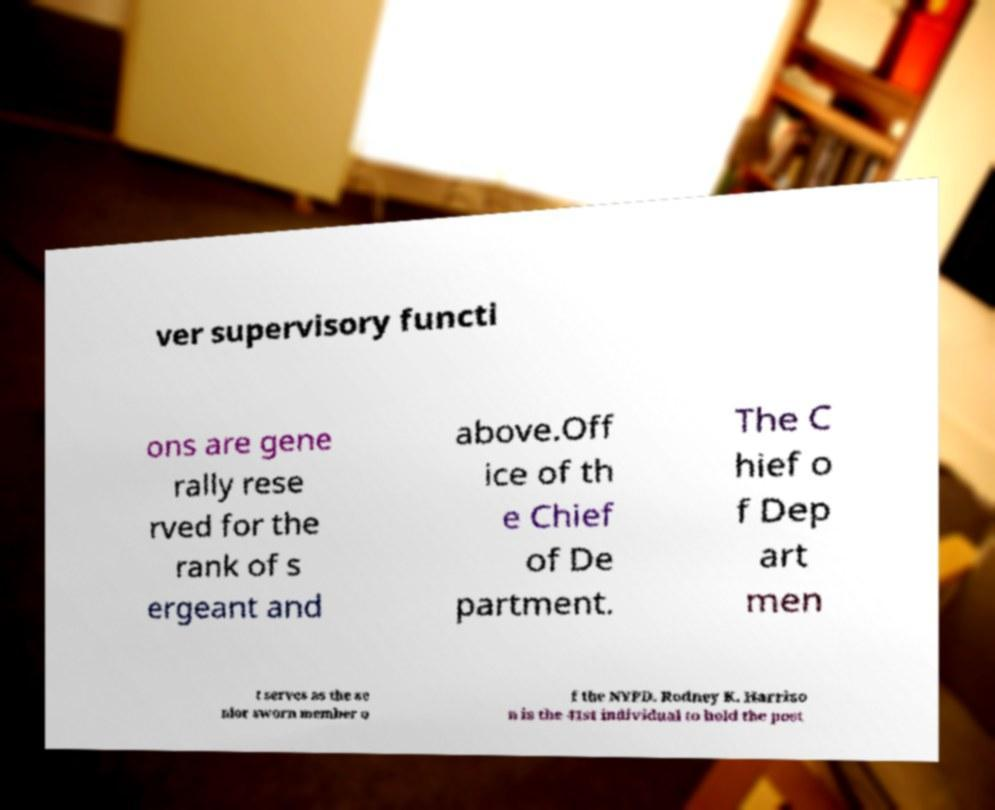Can you read and provide the text displayed in the image?This photo seems to have some interesting text. Can you extract and type it out for me? ver supervisory functi ons are gene rally rese rved for the rank of s ergeant and above.Off ice of th e Chief of De partment. The C hief o f Dep art men t serves as the se nior sworn member o f the NYPD. Rodney K. Harriso n is the 41st individual to hold the post 